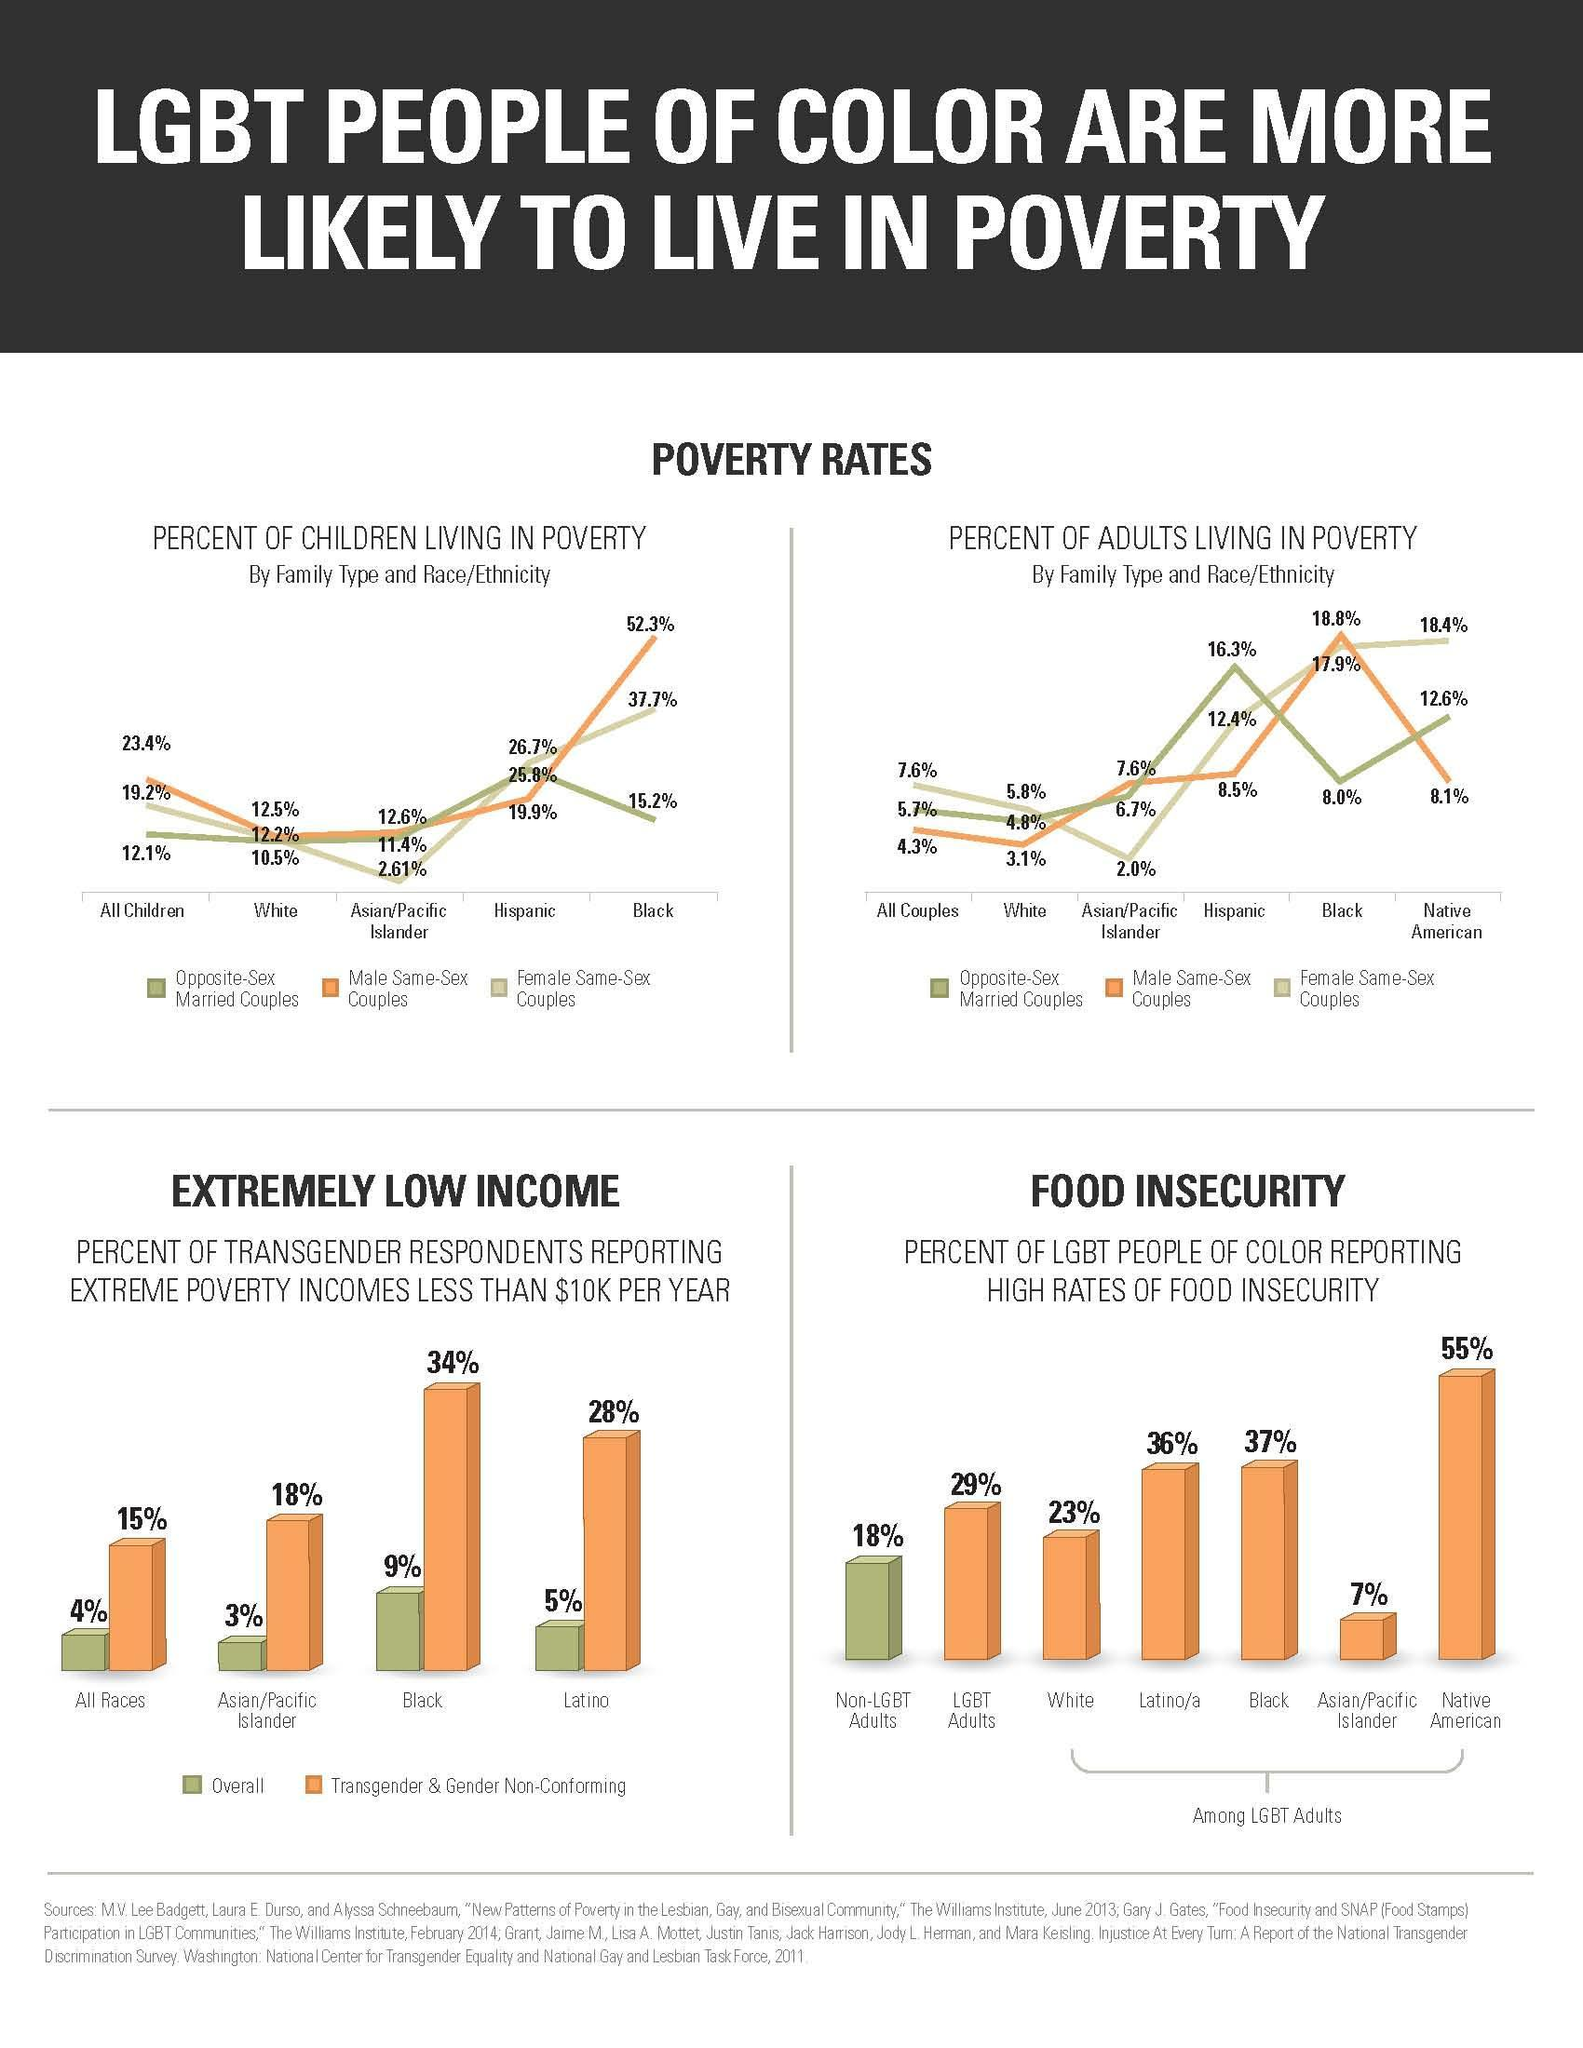which community in food insecurity in the third highest
Answer the question with a short phrase. LGBT adults what is the percentage of adults living in poverty who are white opposite-sex married couples 4.8% what is the percentage of children living in poverty who are hispanic male same-sex couple 19.9% what is the difference between overall and transgender category for the latino community 23 what is the percentage difference in food insecurity between non-lgbt adults and whites 5 